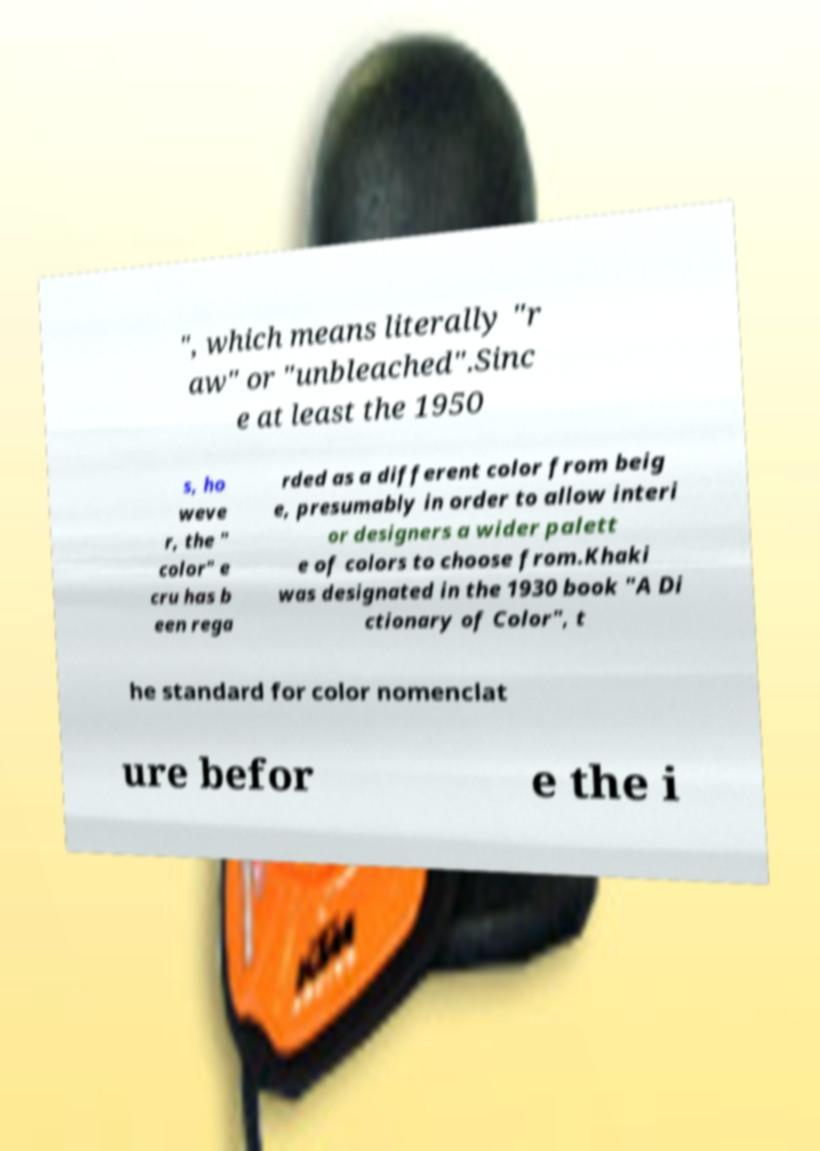Can you accurately transcribe the text from the provided image for me? ", which means literally "r aw" or "unbleached".Sinc e at least the 1950 s, ho weve r, the " color" e cru has b een rega rded as a different color from beig e, presumably in order to allow interi or designers a wider palett e of colors to choose from.Khaki was designated in the 1930 book "A Di ctionary of Color", t he standard for color nomenclat ure befor e the i 